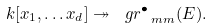<formula> <loc_0><loc_0><loc_500><loc_500>k [ x _ { 1 } , \dots x _ { d } ] \twoheadrightarrow \ g r ^ { \bullet } _ { \ m m } ( E ) .</formula> 